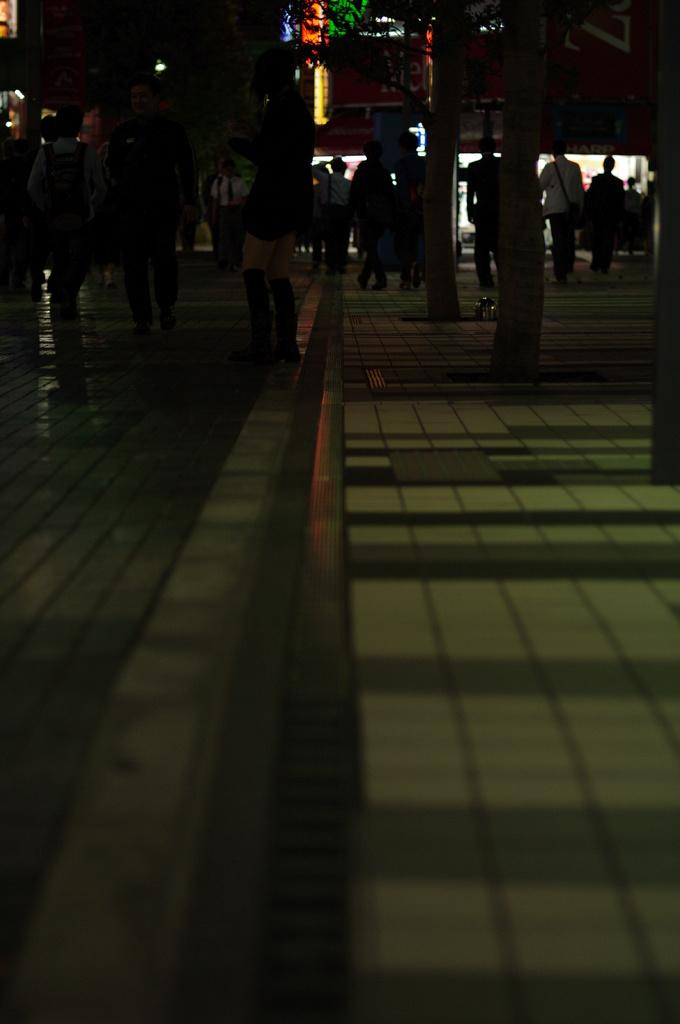What can be seen at the top of the image? At the top of the image, there is a group of people, tree trunks, lights, and banners. What is the location of the walkway in the image? The walkway is at the bottom of the image. Are there any masks visible on the people at the top of the image? There is no mention of masks in the provided facts, so we cannot determine if any masks are present in the image. Can you see any hydrants on the walkway at the bottom of the image? There is no mention of hydrants in the provided facts, so we cannot determine if any hydrants are present in the image. 